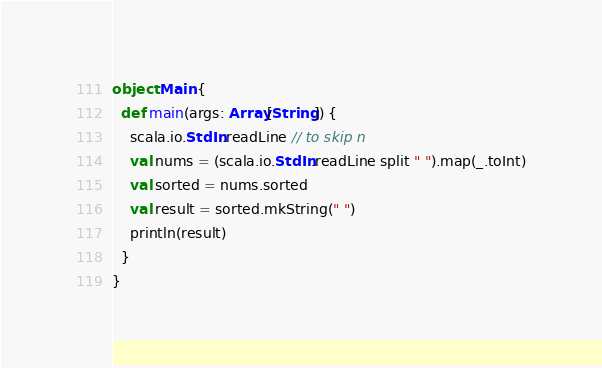<code> <loc_0><loc_0><loc_500><loc_500><_Scala_>object Main {
  def main(args: Array[String]) {
    scala.io.StdIn.readLine // to skip n
    val nums = (scala.io.StdIn.readLine split " ").map(_.toInt)
    val sorted = nums.sorted
    val result = sorted.mkString(" ")
    println(result)
  }
}</code> 